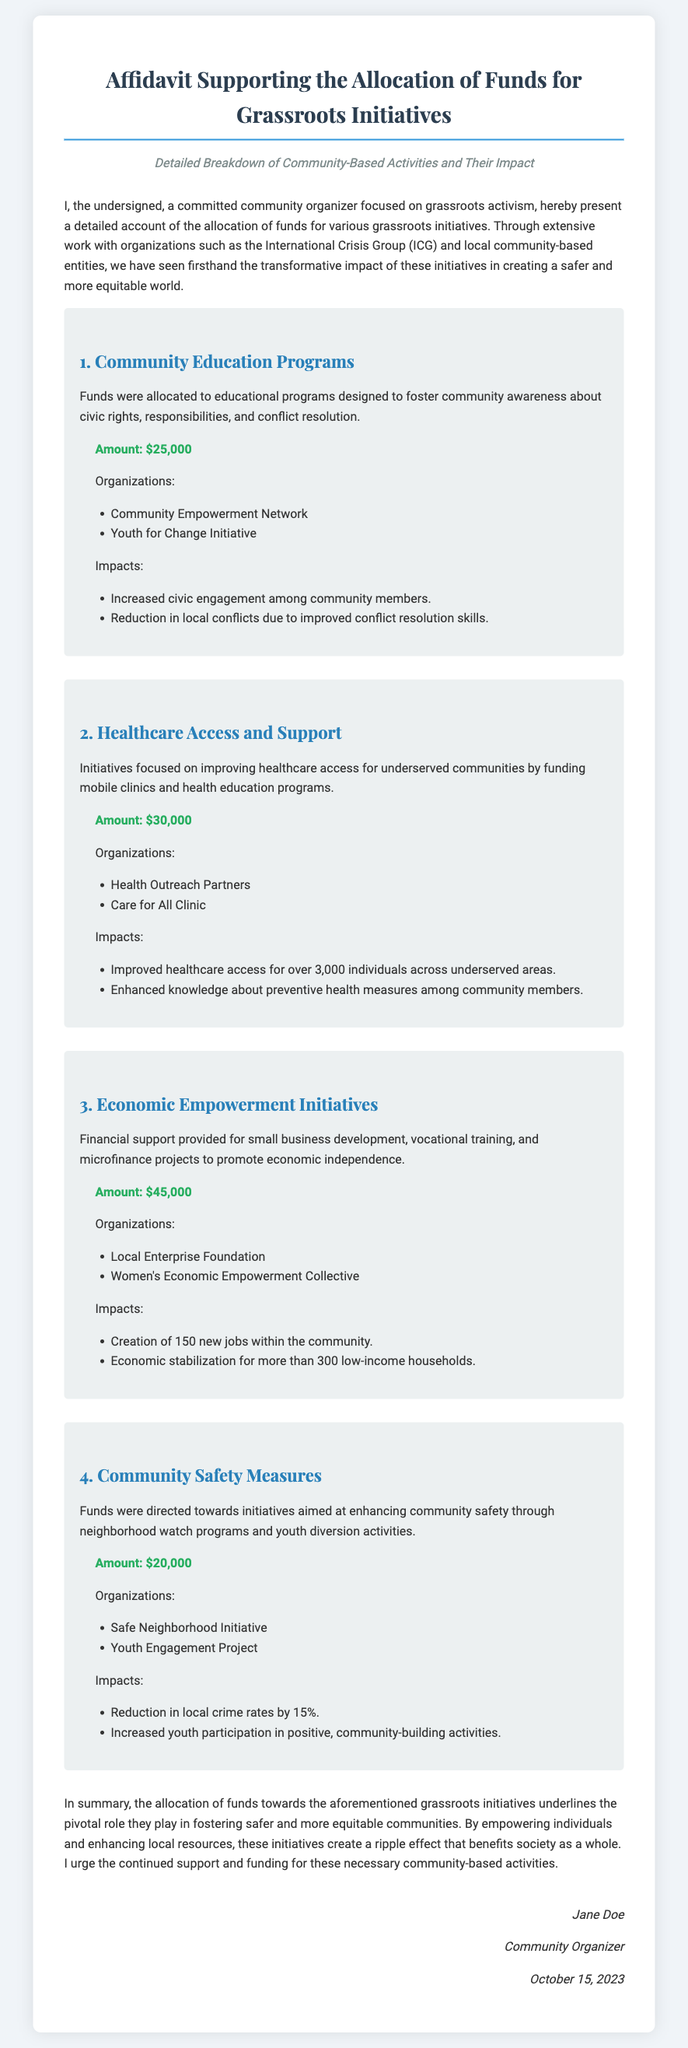What is the total amount allocated for Community Education Programs? The total amount allocated is specified in the document as $25,000 for Community Education Programs.
Answer: $25,000 Which organization focused on improving healthcare access? The document lists "Health Outreach Partners" and "Care for All Clinic" as organizations focusing on healthcare access.
Answer: Health Outreach Partners, Care for All Clinic How many new jobs were created through Economic Empowerment Initiatives? The document states that Economic Empowerment Initiatives created 150 new jobs within the community.
Answer: 150 What was the impact on local crime rates from Community Safety Measures? The document indicates that there was a reduction in local crime rates by 15% due to Community Safety Measures.
Answer: 15% When was the affidavit signed? The signature section of the document mentions that the affidavit was signed on October 15, 2023.
Answer: October 15, 2023 What is the total amount allocated for all initiatives? Summing the amounts allocated for all four initiatives: $25,000 + $30,000 + $45,000 + $20,000 = $120,000 is the total amount allocated.
Answer: $120,000 Which initiative aims to reduce local conflicts? The Community Education Programs initiative is designed to reduce local conflicts through improved conflict resolution skills.
Answer: Community Education Programs What type of programs did the Healthcare Access and Support initiative include? The Healthcare Access and Support initiative included mobile clinics and health education programs.
Answer: Mobile clinics and health education programs 